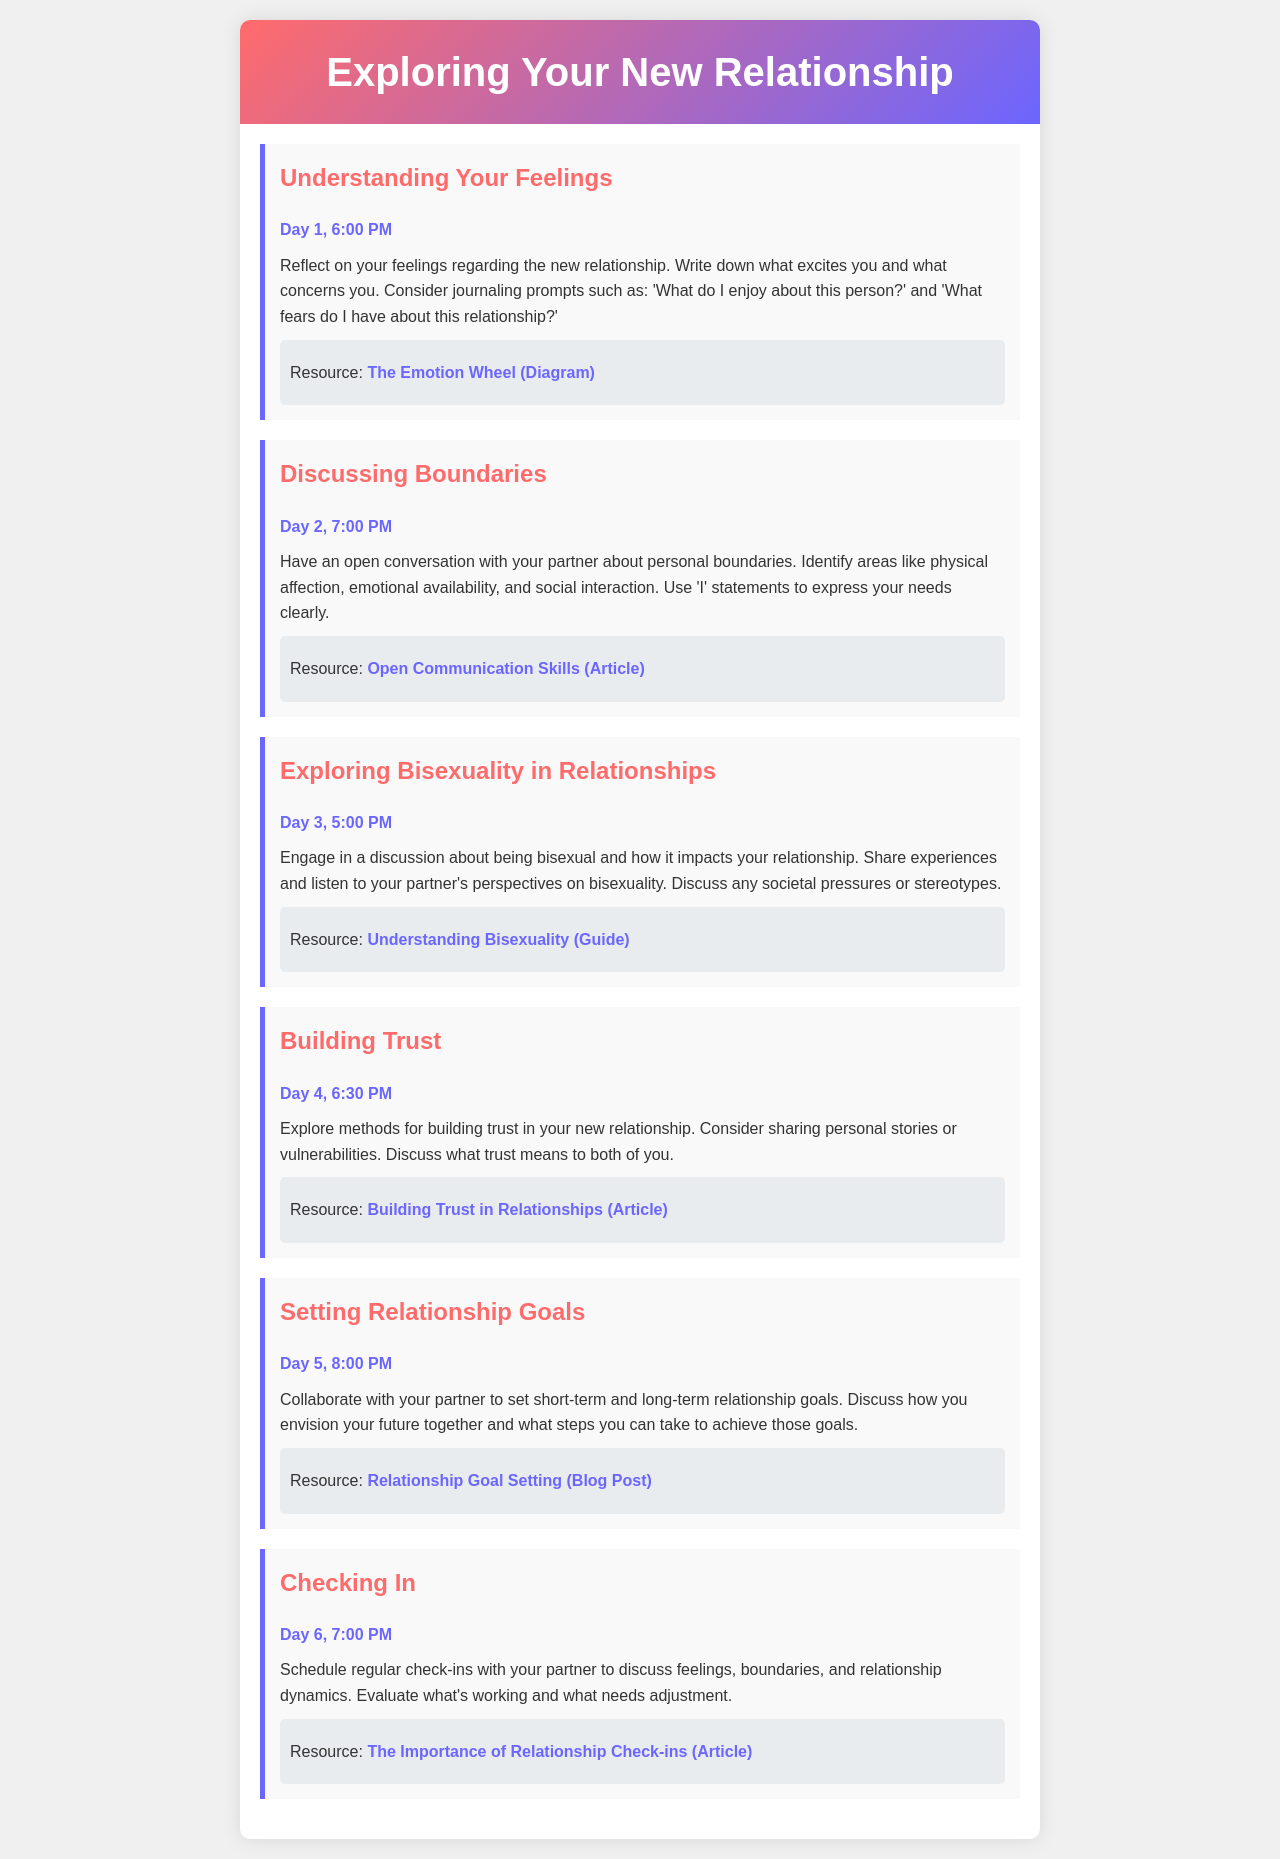What is the title of the document? The title is provided in the header section of the document.
Answer: Exploring Your New Relationship What is the date and time for the session on understanding feelings? The date and time for the session are specified directly under the session title.
Answer: Day 1, 6:00 PM What is discussed in the session on Day 3? The content of the session is described in the paragraph under the session title.
Answer: Exploring Bisexuality in Relationships What type of statements should be used to express needs in the boundaries session? The document mentions the use of specific types of statements for effective communication.
Answer: 'I' statements How many sessions are listed in the document? The document outlines a specific number of sessions for exploring the relationship.
Answer: Six sessions What should you do on Day 6? The activity for Day 6 is described under the session title.
Answer: Checking In What is the focus of the second session? The subject of the second session is stated in the title and explained in the description.
Answer: Discussing Boundaries What is one recommended resource for building trust? Resources are provided for further reading or guidance in each session.
Answer: Building Trust in Relationships What time is the goal-setting session on Day 5? The document specifies the exact time for this particular session.
Answer: 8:00 PM 